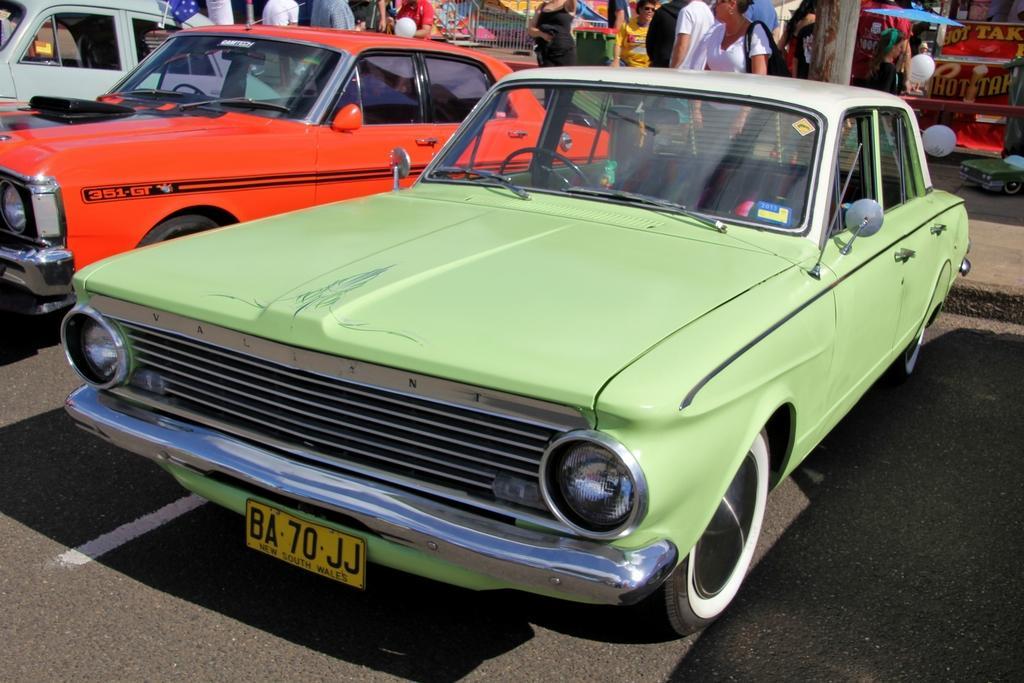How would you summarize this image in a sentence or two? Vehicles are on the road. To this vehicle there is a number plate and wheels. Background there are people, grill, umbrella, balloons and stall. 